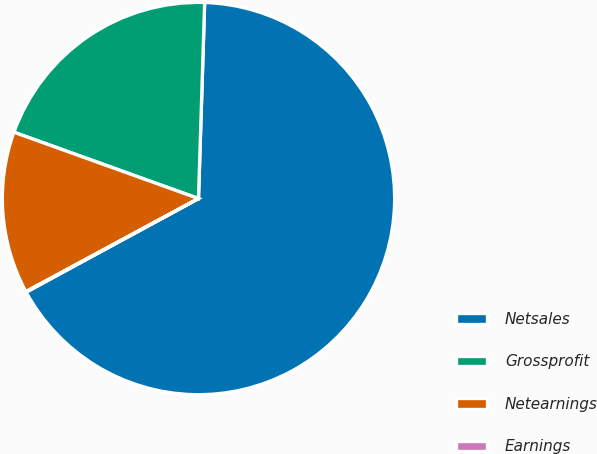Convert chart. <chart><loc_0><loc_0><loc_500><loc_500><pie_chart><fcel>Netsales<fcel>Grossprofit<fcel>Netearnings<fcel>Earnings<nl><fcel>66.58%<fcel>20.01%<fcel>13.36%<fcel>0.05%<nl></chart> 